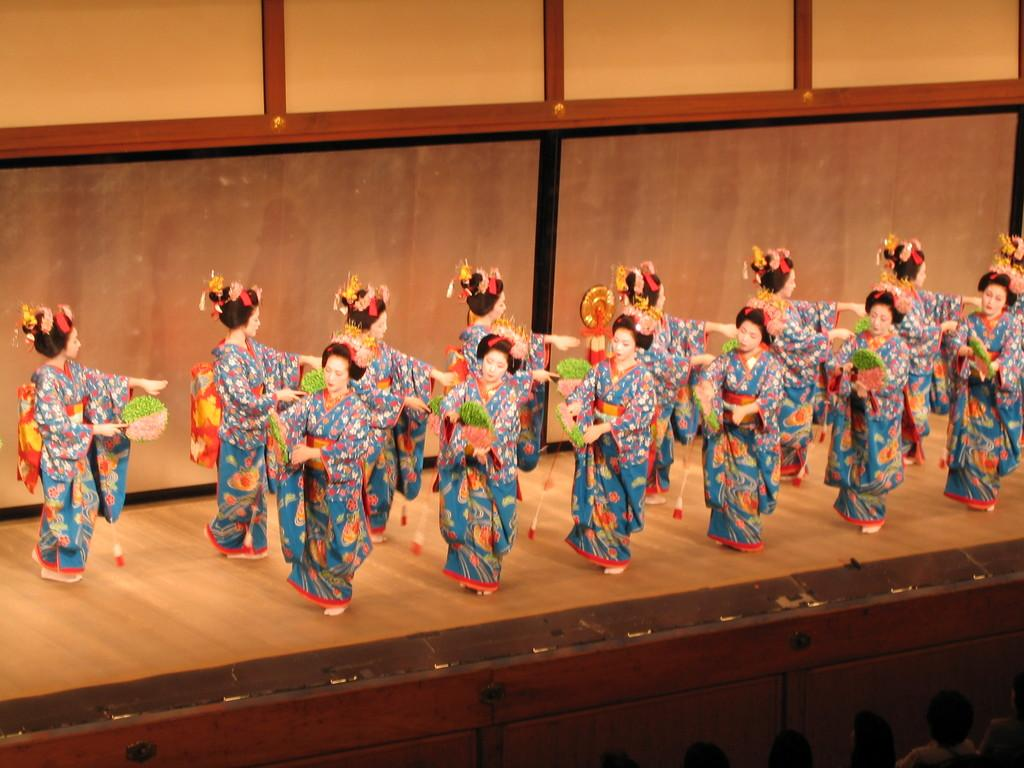What are the women in the image doing? The women in the image are performing. Where are the women performing? The women are performing on a dais. Who can be seen at the bottom of the image? There are persons at the bottom of the image. What is visible in the background of the image? There is a wall in the background of the image. What type of pleasure can be seen on the feet of the women in the image? There is no indication of pleasure or feet in the image, as it focuses on the women performing on a dais. 